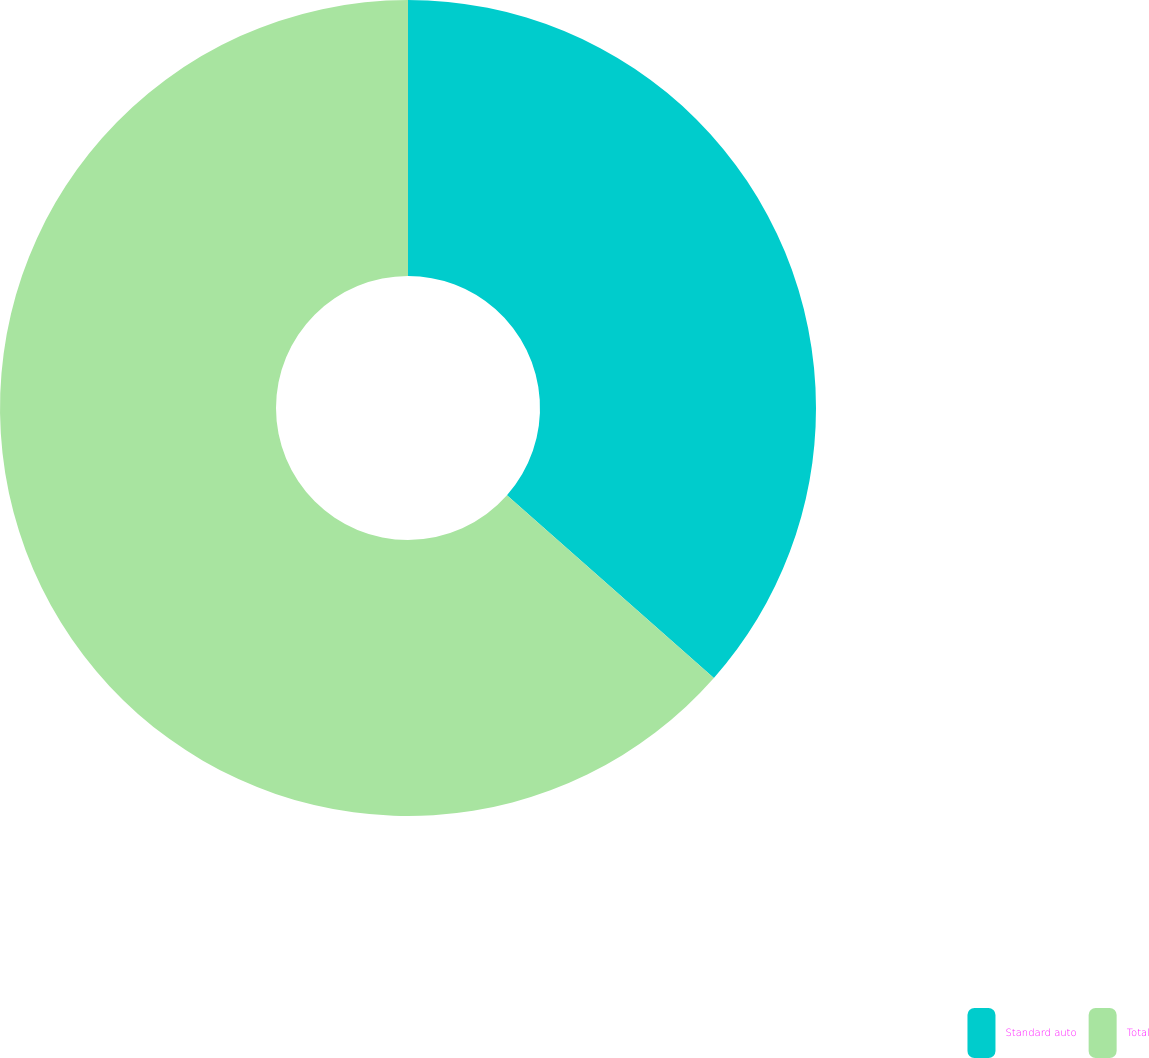Convert chart to OTSL. <chart><loc_0><loc_0><loc_500><loc_500><pie_chart><fcel>Standard auto<fcel>Total<nl><fcel>36.51%<fcel>63.49%<nl></chart> 